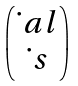<formula> <loc_0><loc_0><loc_500><loc_500>\begin{pmatrix} \dot { \ } a l \\ \dot { \ } s \end{pmatrix}</formula> 